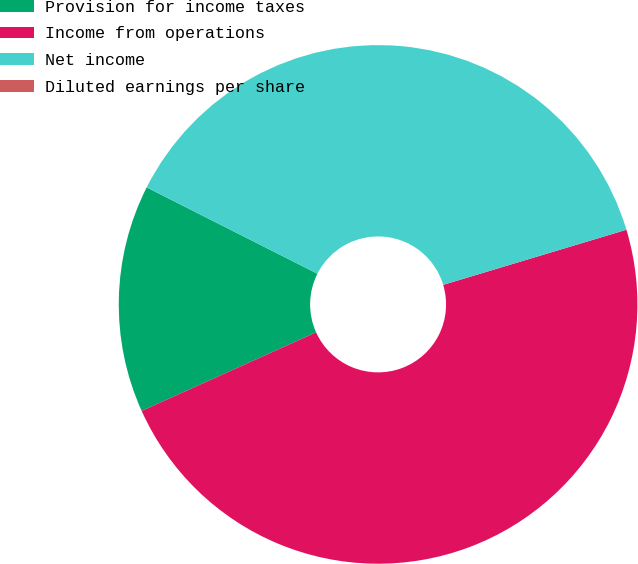Convert chart to OTSL. <chart><loc_0><loc_0><loc_500><loc_500><pie_chart><fcel>Provision for income taxes<fcel>Income from operations<fcel>Net income<fcel>Diluted earnings per share<nl><fcel>14.19%<fcel>47.91%<fcel>37.9%<fcel>0.0%<nl></chart> 